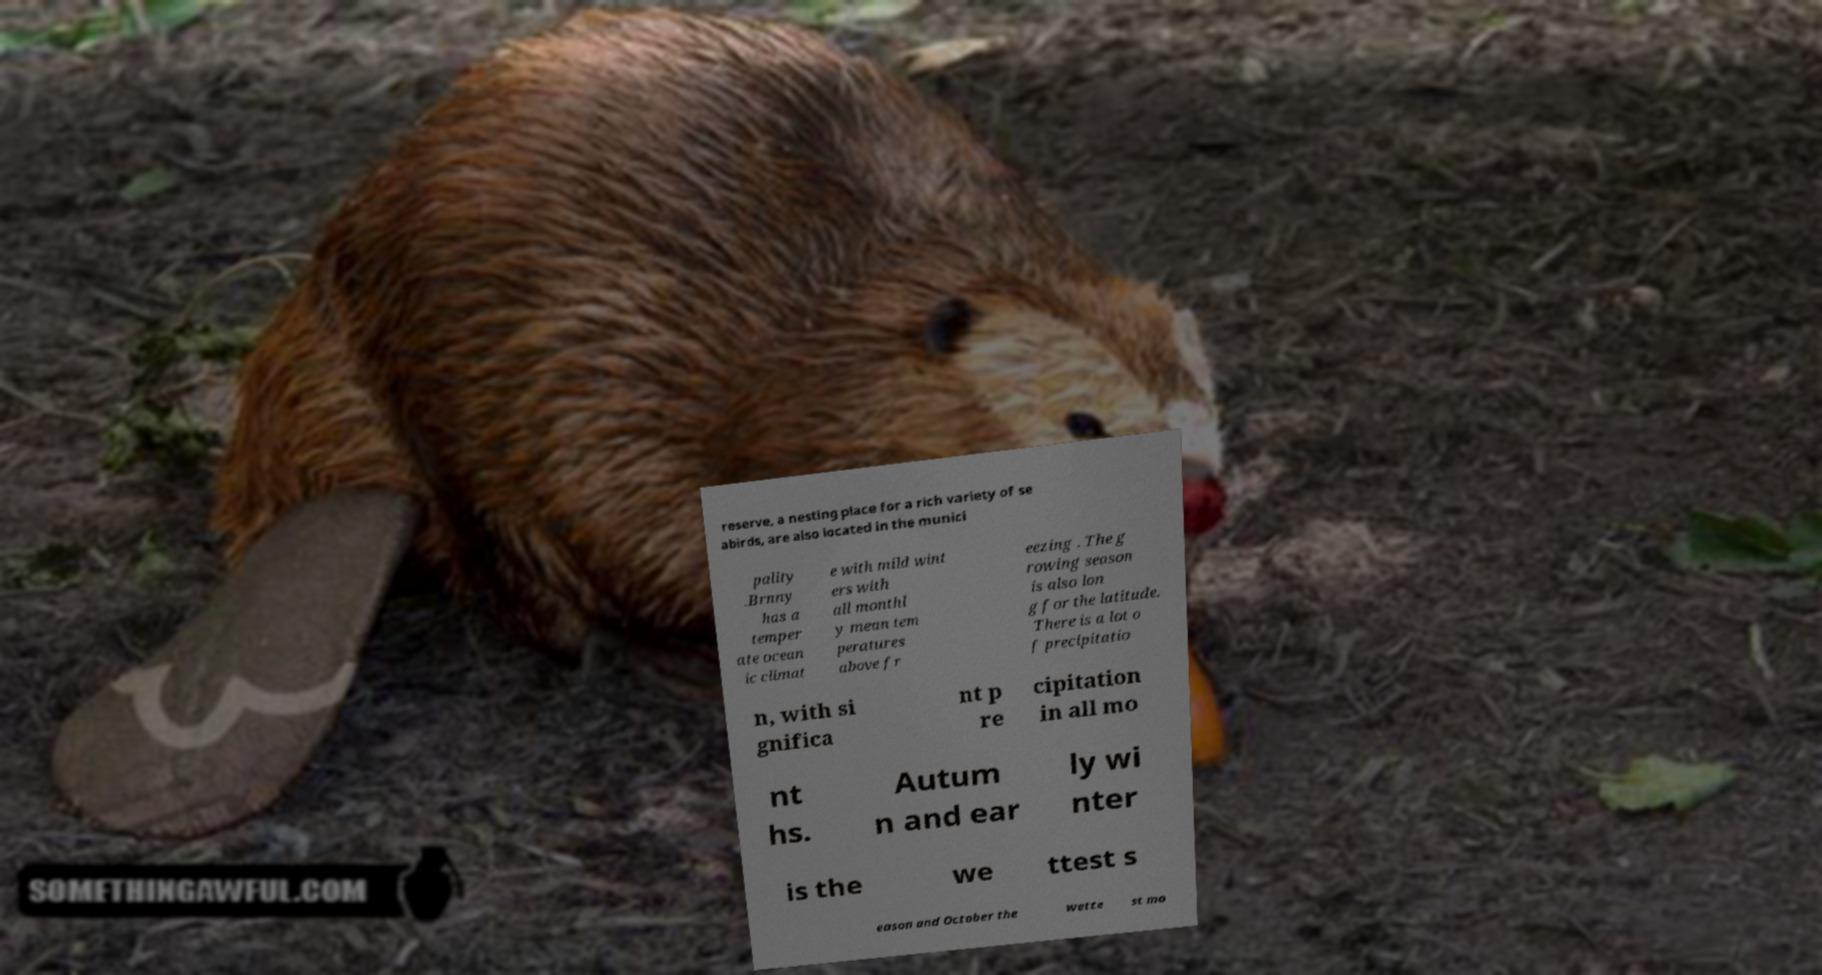Can you read and provide the text displayed in the image?This photo seems to have some interesting text. Can you extract and type it out for me? reserve, a nesting place for a rich variety of se abirds, are also located in the munici pality .Brnny has a temper ate ocean ic climat e with mild wint ers with all monthl y mean tem peratures above fr eezing . The g rowing season is also lon g for the latitude. There is a lot o f precipitatio n, with si gnifica nt p re cipitation in all mo nt hs. Autum n and ear ly wi nter is the we ttest s eason and October the wette st mo 